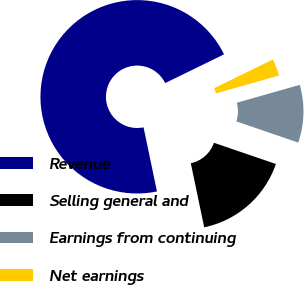<chart> <loc_0><loc_0><loc_500><loc_500><pie_chart><fcel>Revenue<fcel>Selling general and<fcel>Earnings from continuing<fcel>Net earnings<nl><fcel>71.05%<fcel>16.47%<fcel>9.65%<fcel>2.83%<nl></chart> 